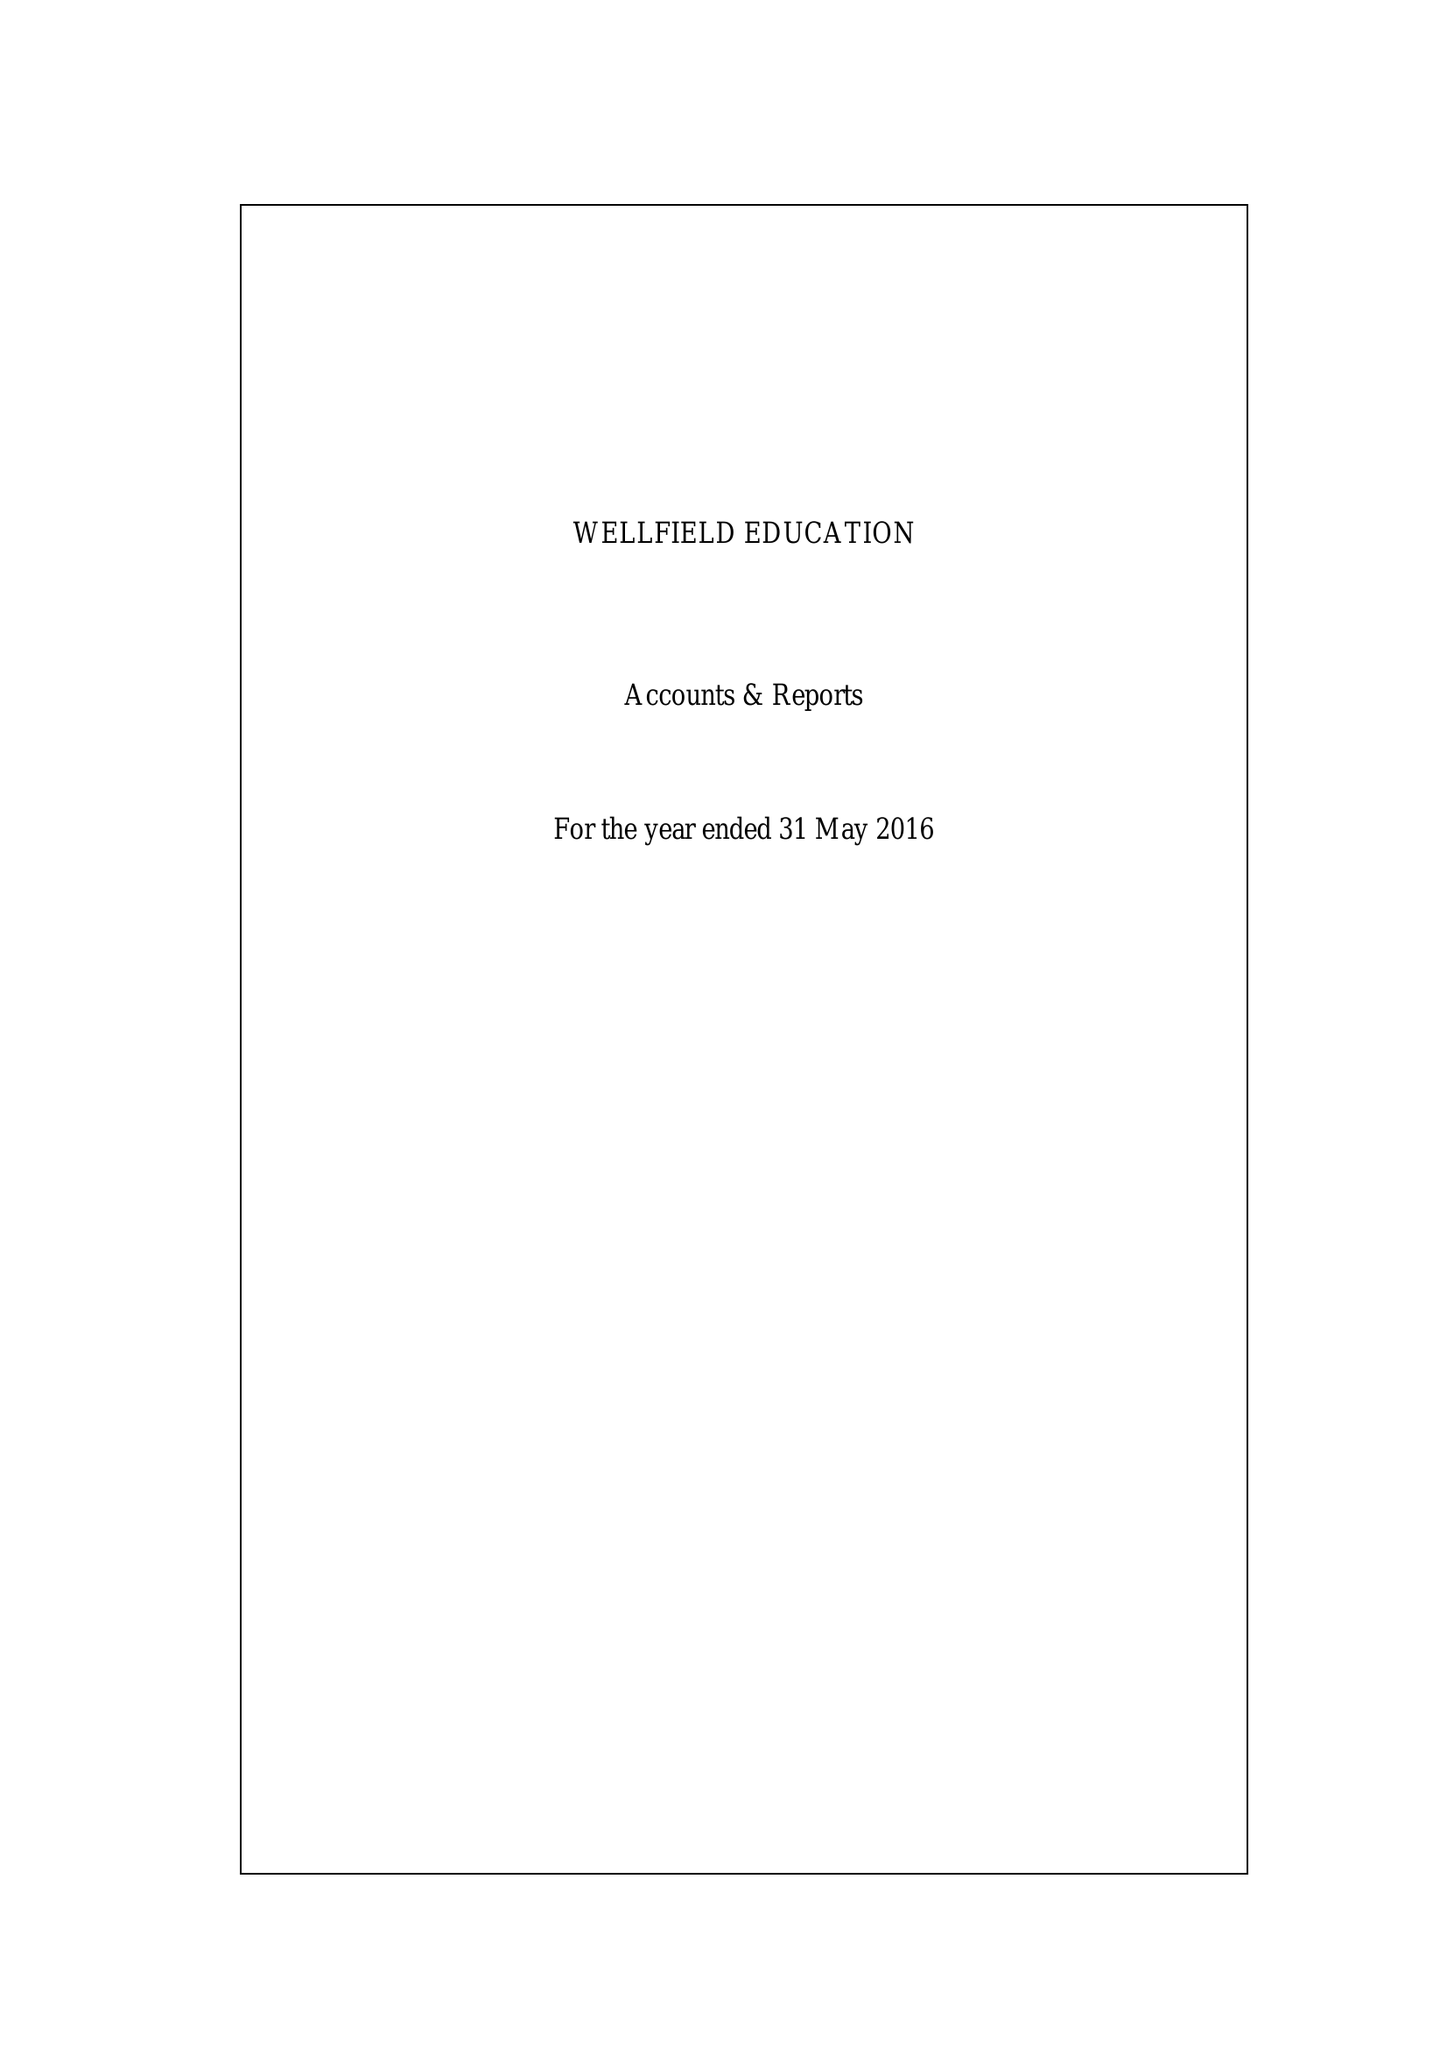What is the value for the report_date?
Answer the question using a single word or phrase. 2016-05-31 